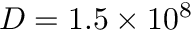<formula> <loc_0><loc_0><loc_500><loc_500>D = 1 . 5 \times 1 0 ^ { 8 }</formula> 